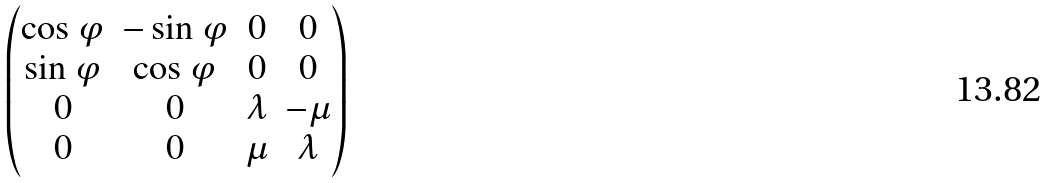Convert formula to latex. <formula><loc_0><loc_0><loc_500><loc_500>\begin{pmatrix} \cos \varphi & - \sin \varphi & 0 & 0 \\ \sin \varphi & \cos \varphi & 0 & 0 \\ 0 & 0 & \lambda & - \mu \\ 0 & 0 & \mu & \lambda \end{pmatrix}</formula> 